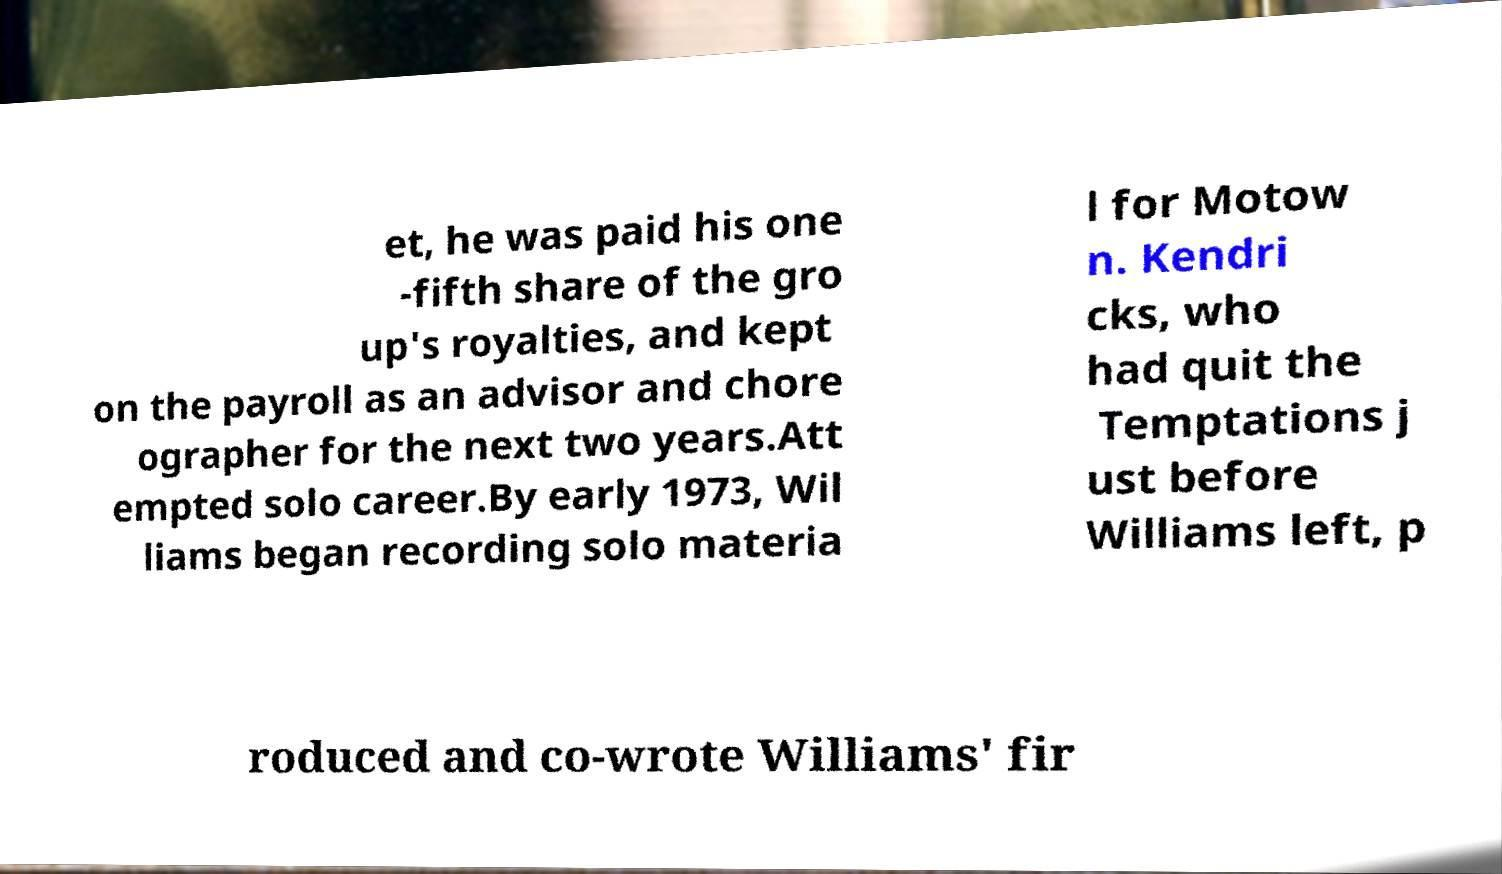Can you read and provide the text displayed in the image?This photo seems to have some interesting text. Can you extract and type it out for me? et, he was paid his one -fifth share of the gro up's royalties, and kept on the payroll as an advisor and chore ographer for the next two years.Att empted solo career.By early 1973, Wil liams began recording solo materia l for Motow n. Kendri cks, who had quit the Temptations j ust before Williams left, p roduced and co-wrote Williams' fir 